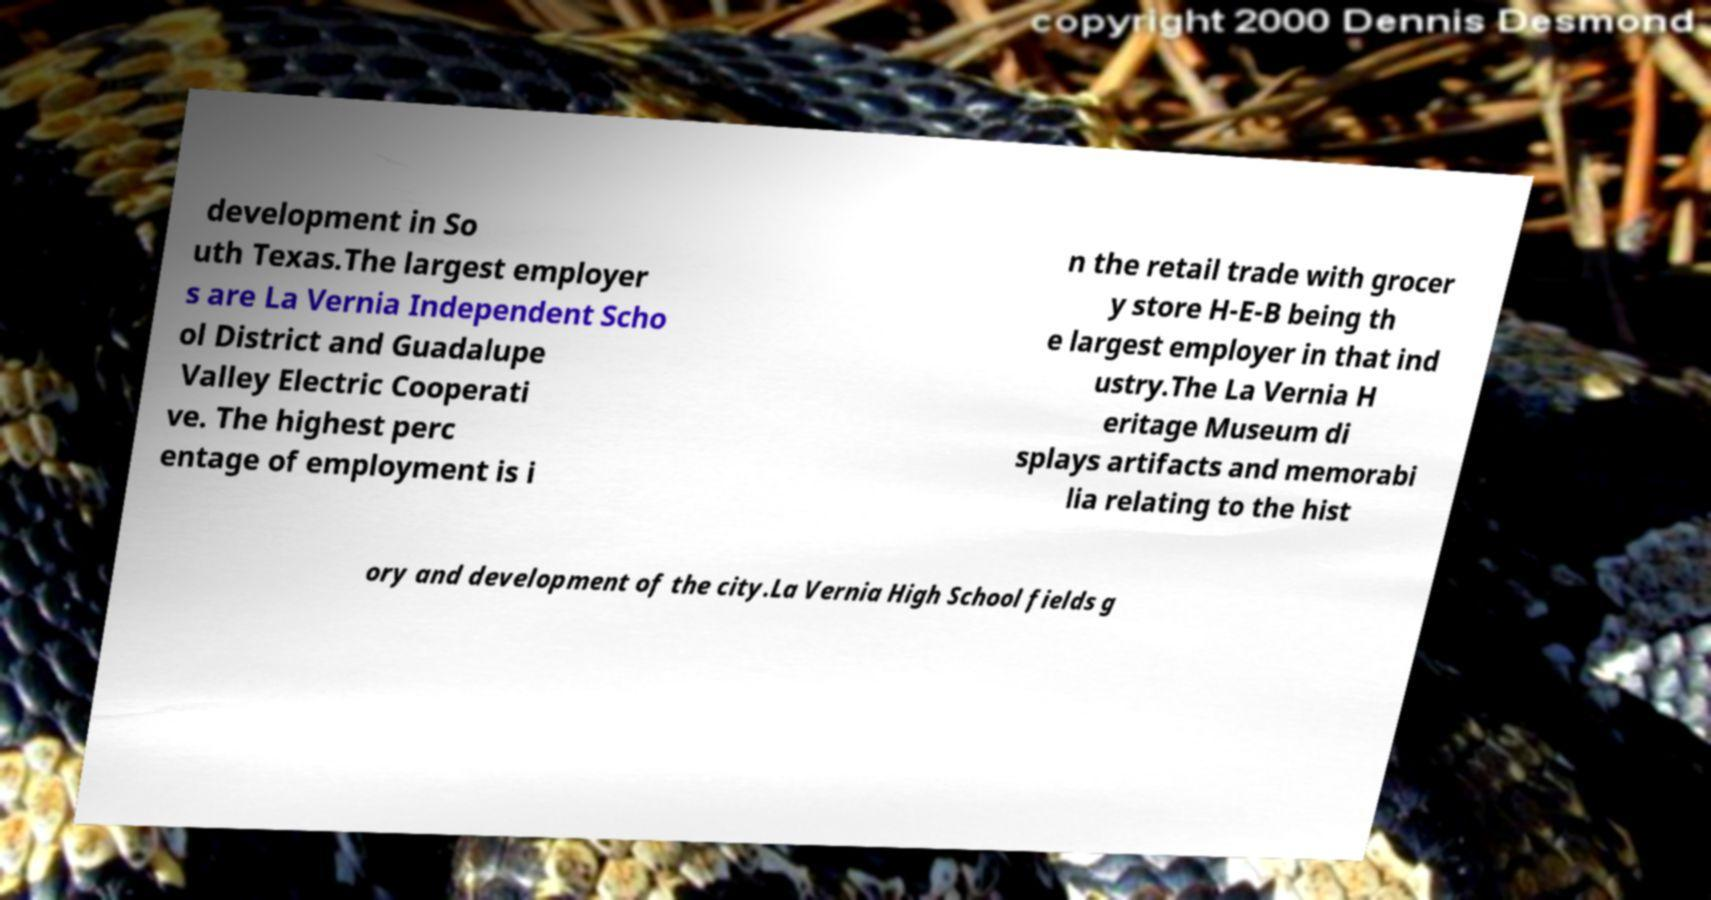Could you extract and type out the text from this image? development in So uth Texas.The largest employer s are La Vernia Independent Scho ol District and Guadalupe Valley Electric Cooperati ve. The highest perc entage of employment is i n the retail trade with grocer y store H-E-B being th e largest employer in that ind ustry.The La Vernia H eritage Museum di splays artifacts and memorabi lia relating to the hist ory and development of the city.La Vernia High School fields g 